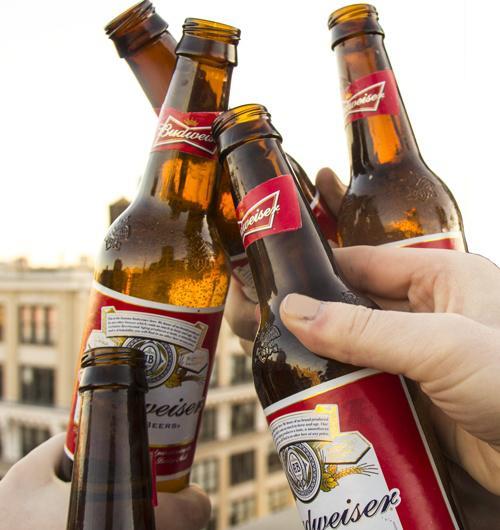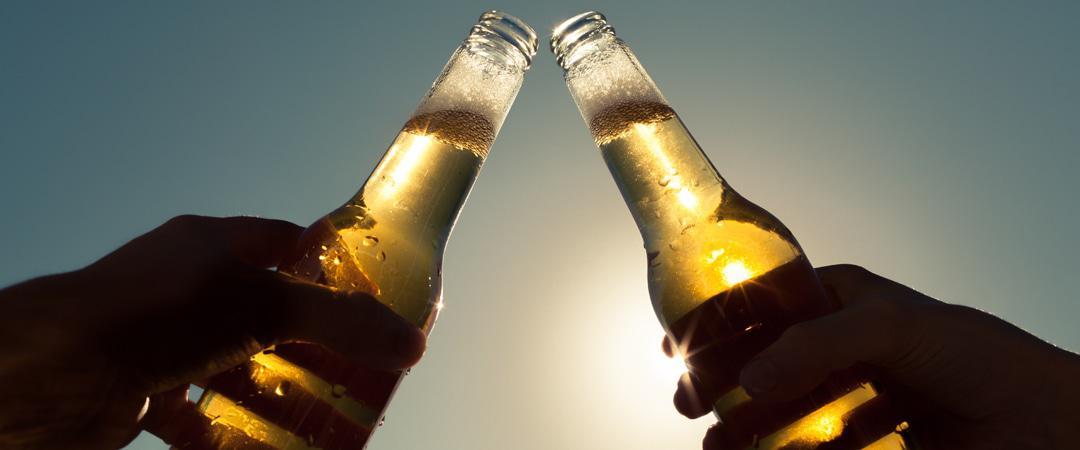The first image is the image on the left, the second image is the image on the right. Assess this claim about the two images: "There are exactly four bottles being toasted, two in each image.". Correct or not? Answer yes or no. No. 